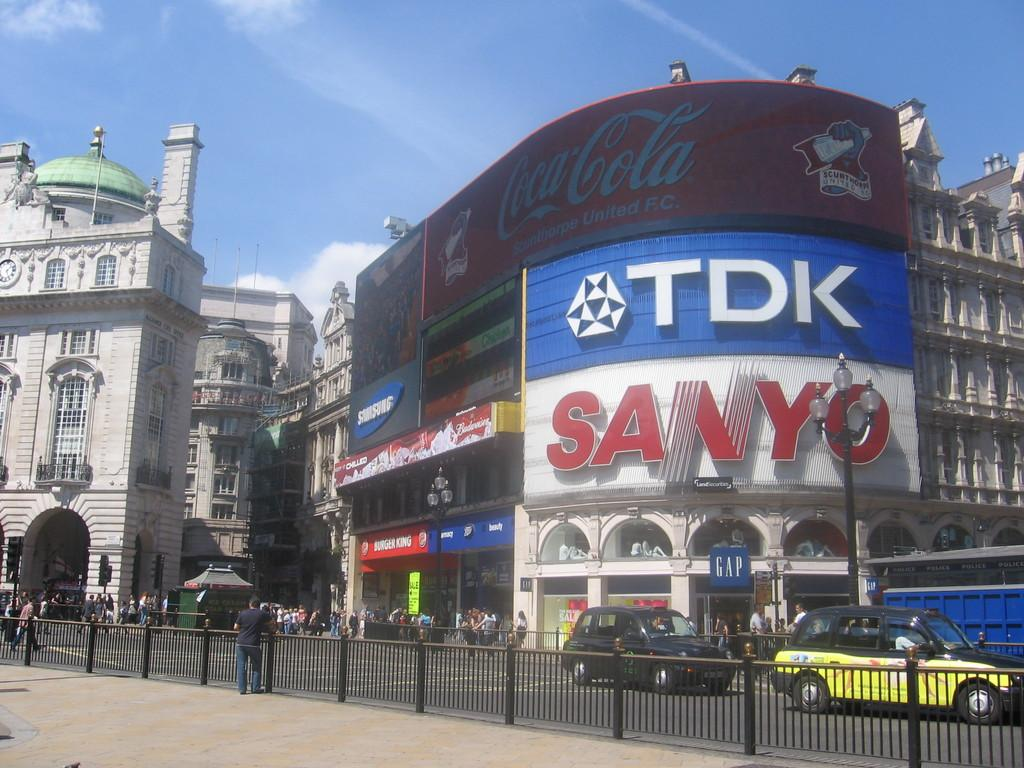<image>
Render a clear and concise summary of the photo. A building has large advertisements for TDK and SANYO. 